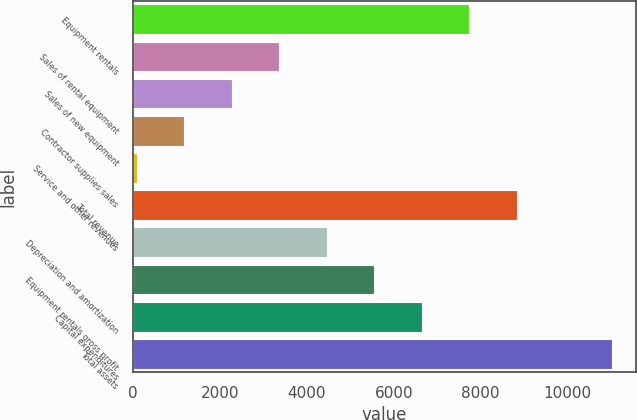Convert chart. <chart><loc_0><loc_0><loc_500><loc_500><bar_chart><fcel>Equipment rentals<fcel>Sales of rental equipment<fcel>Sales of new equipment<fcel>Contractor supplies sales<fcel>Service and other revenues<fcel>Total revenue<fcel>Depreciation and amortization<fcel>Equipment rentals gross profit<fcel>Capital expenditures<fcel>Total assets<nl><fcel>7743.1<fcel>3365.9<fcel>2271.6<fcel>1177.3<fcel>83<fcel>8837.4<fcel>4460.2<fcel>5554.5<fcel>6648.8<fcel>11026<nl></chart> 